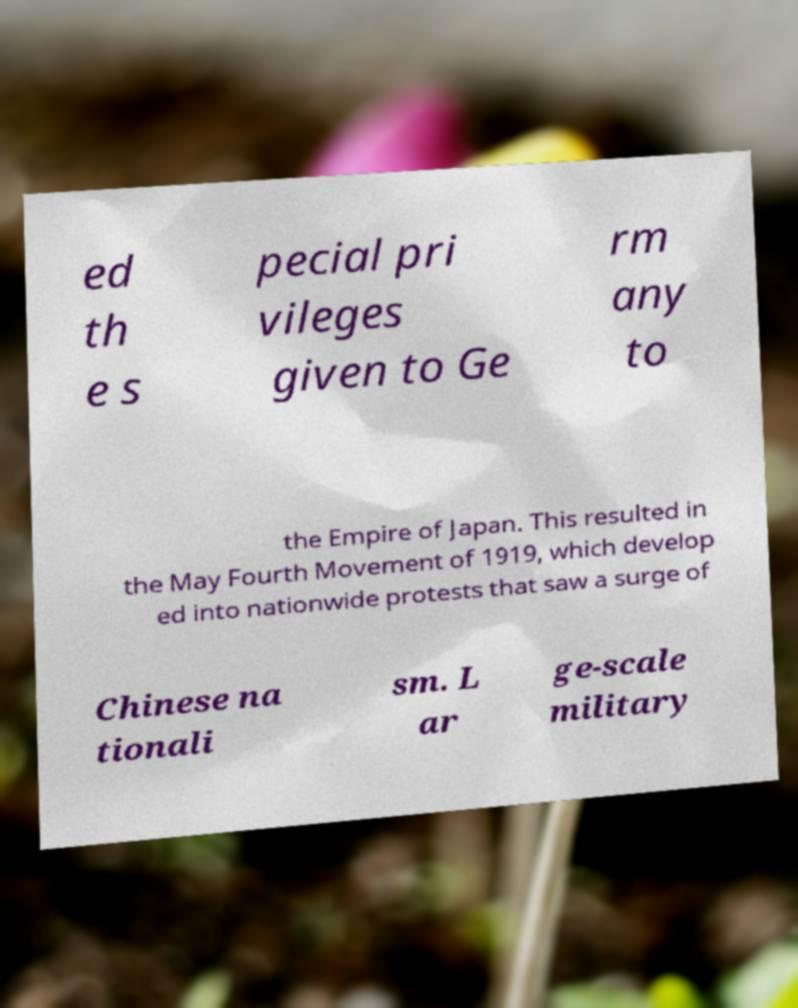Could you extract and type out the text from this image? ed th e s pecial pri vileges given to Ge rm any to the Empire of Japan. This resulted in the May Fourth Movement of 1919, which develop ed into nationwide protests that saw a surge of Chinese na tionali sm. L ar ge-scale military 